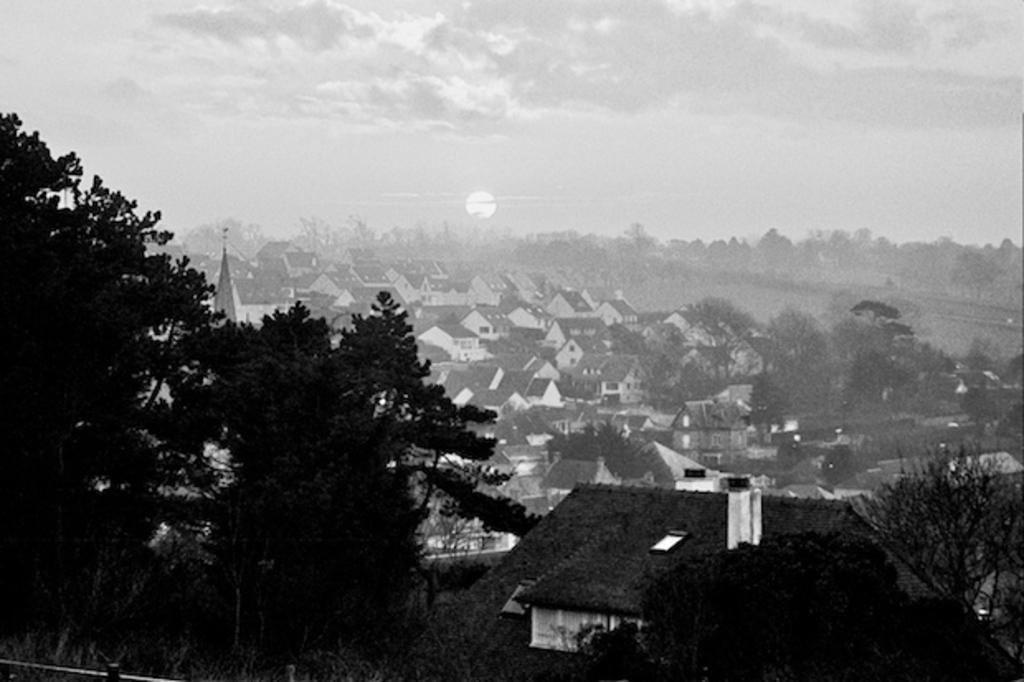Can you describe this image briefly? This is a black and white image. In this image, we can see trees, plants and house. In the background, there are so many houses, trees and cloudy sky. 